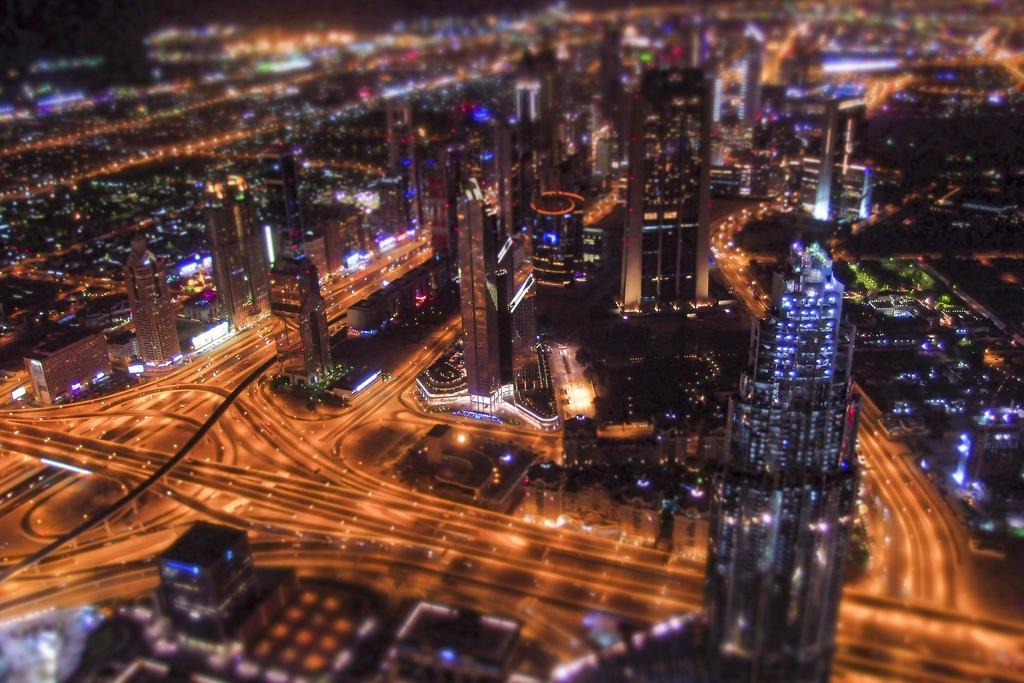Can you describe this image briefly? In this picture we can see buildings, roads, lights and in the background it is blurry. 